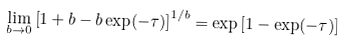Convert formula to latex. <formula><loc_0><loc_0><loc_500><loc_500>\lim _ { b \to 0 } \left [ 1 + b - b \exp ( - \tau ) \right ] ^ { 1 / b } = \exp \left [ 1 - \exp ( - \tau ) \right ]</formula> 